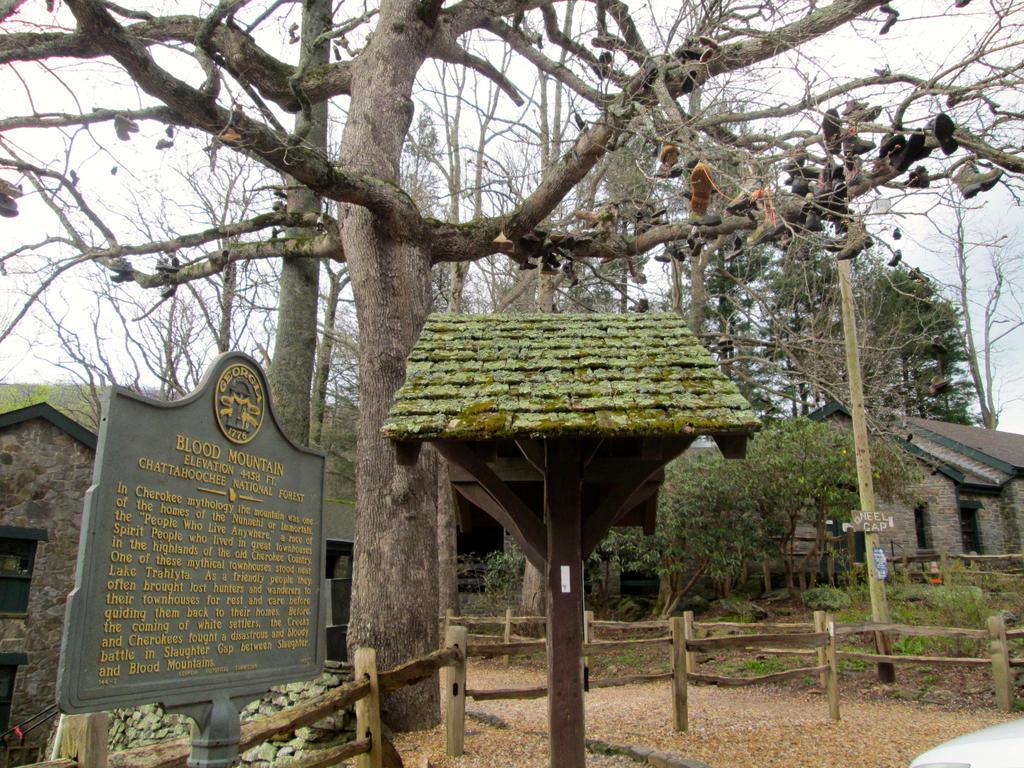How would you summarize this image in a sentence or two? In this image, I can see the trees. At the center of the image, It looks like a shelter. At the bottom of the image, I can see the wooden fence and plants. I can see the shoes, which are hanging to the trees. On the left side of the image, that looks like a board with the letters written on it. In the background, I think these are the houses. 